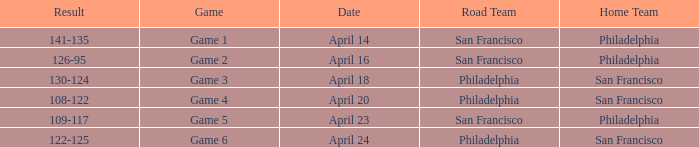Which game had Philadelphia as its home team and was played on April 23? Game 5. 